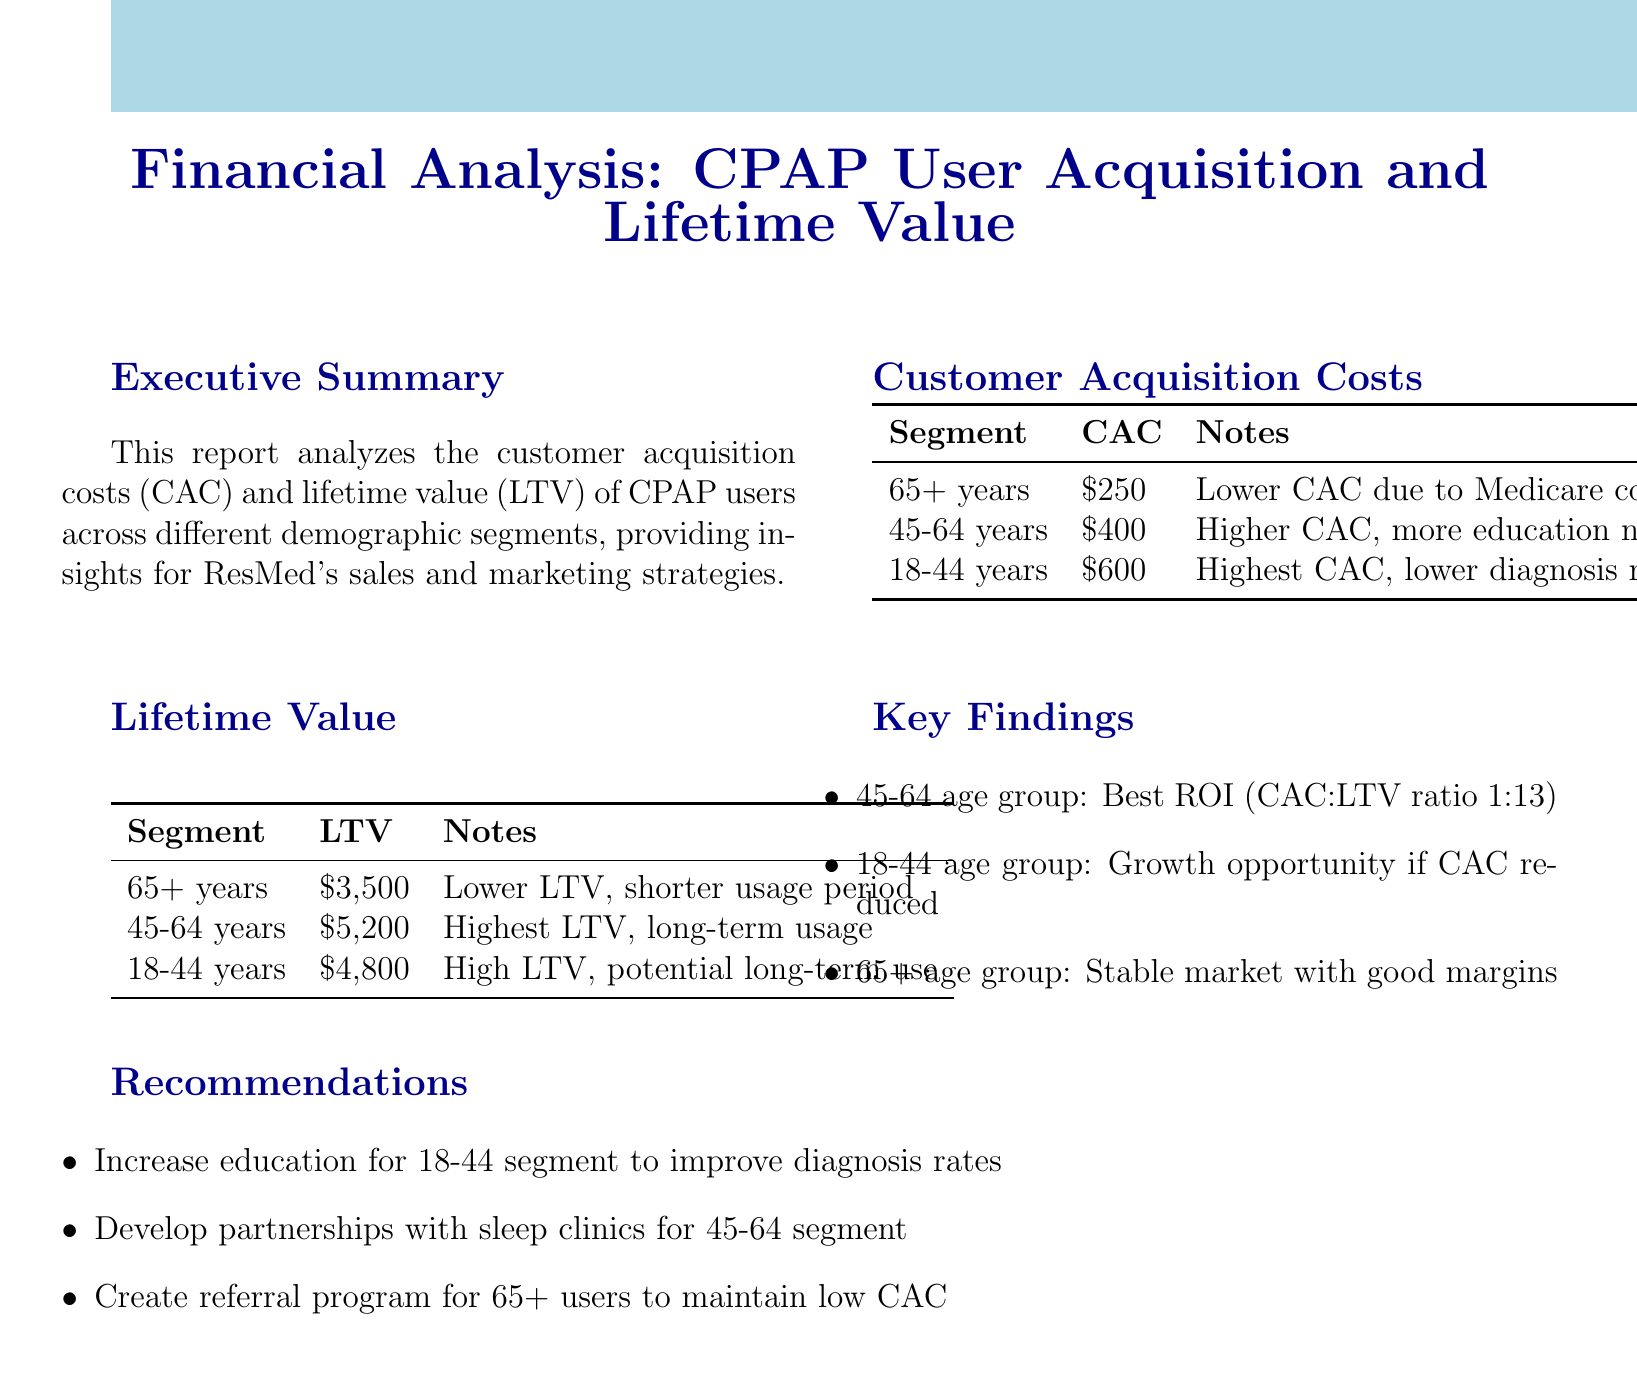What is the title of the report? The title of the report is listed at the beginning of the document.
Answer: Financial Analysis: CPAP User Acquisition and Lifetime Value by Demographics What is the customer acquisition cost for the 45-64 age group? The document specifies the CAC for this segment in the Customer Acquisition Costs section.
Answer: $400 What is the lifetime value of CPAP users aged 65 and older? The LTV for this demographic is mentioned in the Lifetime Value section of the report.
Answer: $3,500 Which demographic segment has the highest customer acquisition cost? The document provides a comparison of CAC across different segments.
Answer: 18-44 years What is the CAC:LTV ratio for the 45-64 age group? This ratio is noted among the key findings derived from CAC and LTV values.
Answer: 1:13 What recommendation is made for the 18-44 demographic? The recommendations section outlines specific strategies targeted at different groups.
Answer: Increase educational efforts What finding suggests a growth opportunity? This insight is mentioned in the Key Findings section, highlighting a specific demographic.
Answer: Young adults (18-44) What is noted as a driving factor for lower CAC in seniors? The document notes specific reasons for CAC differences in demographics.
Answer: Medicare coverage What does the report suggest regarding partnerships for the 45-64 segment? There is a specific recommendation concerning collaborations with other entities for this group.
Answer: Develop partnerships with sleep clinics 